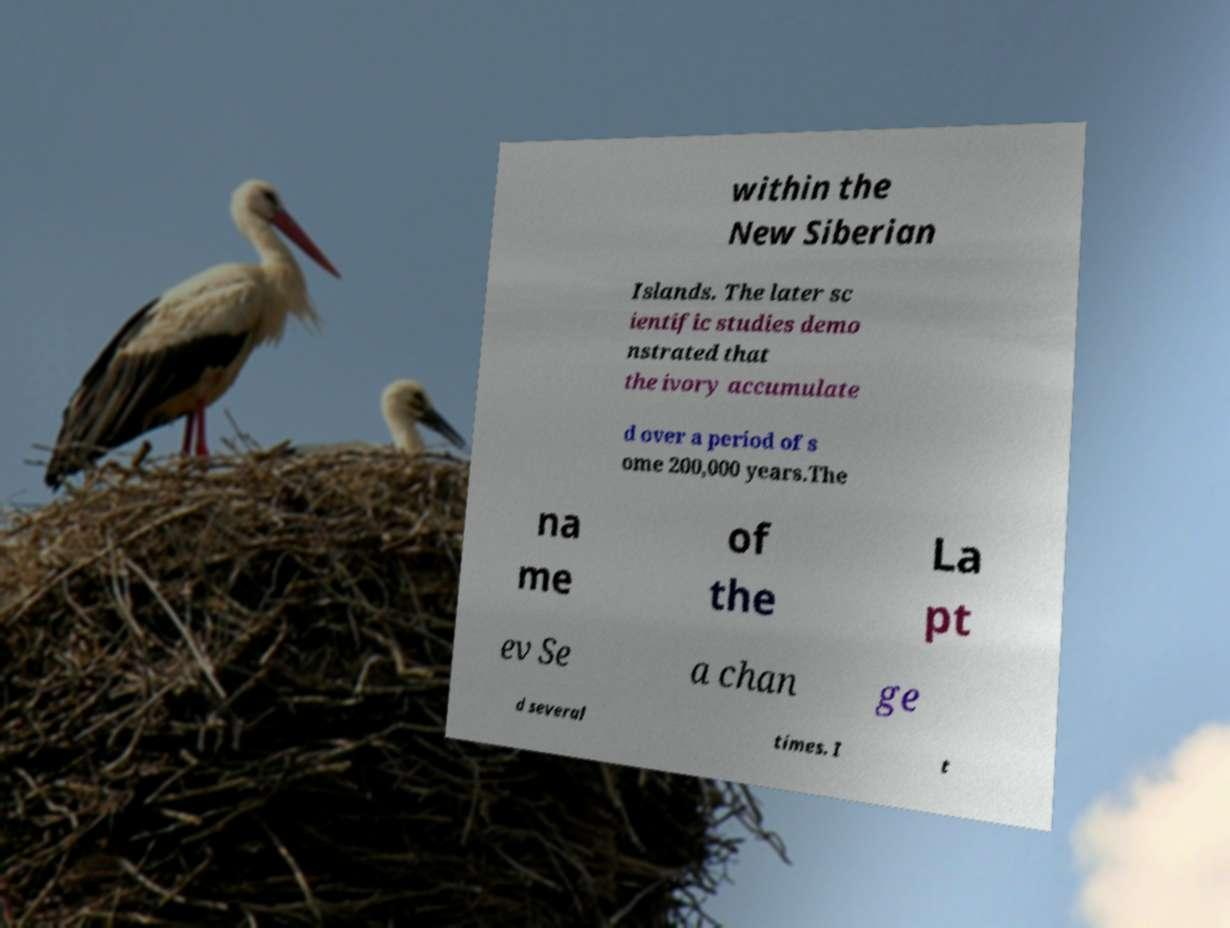Can you read and provide the text displayed in the image?This photo seems to have some interesting text. Can you extract and type it out for me? within the New Siberian Islands. The later sc ientific studies demo nstrated that the ivory accumulate d over a period of s ome 200,000 years.The na me of the La pt ev Se a chan ge d several times. I t 